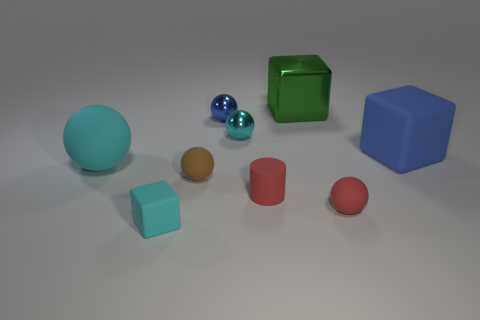Subtract 1 blocks. How many blocks are left? 2 Subtract all blue spheres. How many spheres are left? 4 Subtract all red spheres. How many spheres are left? 4 Subtract all brown spheres. Subtract all brown cylinders. How many spheres are left? 4 Add 1 blue rubber things. How many objects exist? 10 Subtract all cylinders. How many objects are left? 8 Subtract 1 green cubes. How many objects are left? 8 Subtract all big blocks. Subtract all brown objects. How many objects are left? 6 Add 2 big cyan things. How many big cyan things are left? 3 Add 3 yellow cylinders. How many yellow cylinders exist? 3 